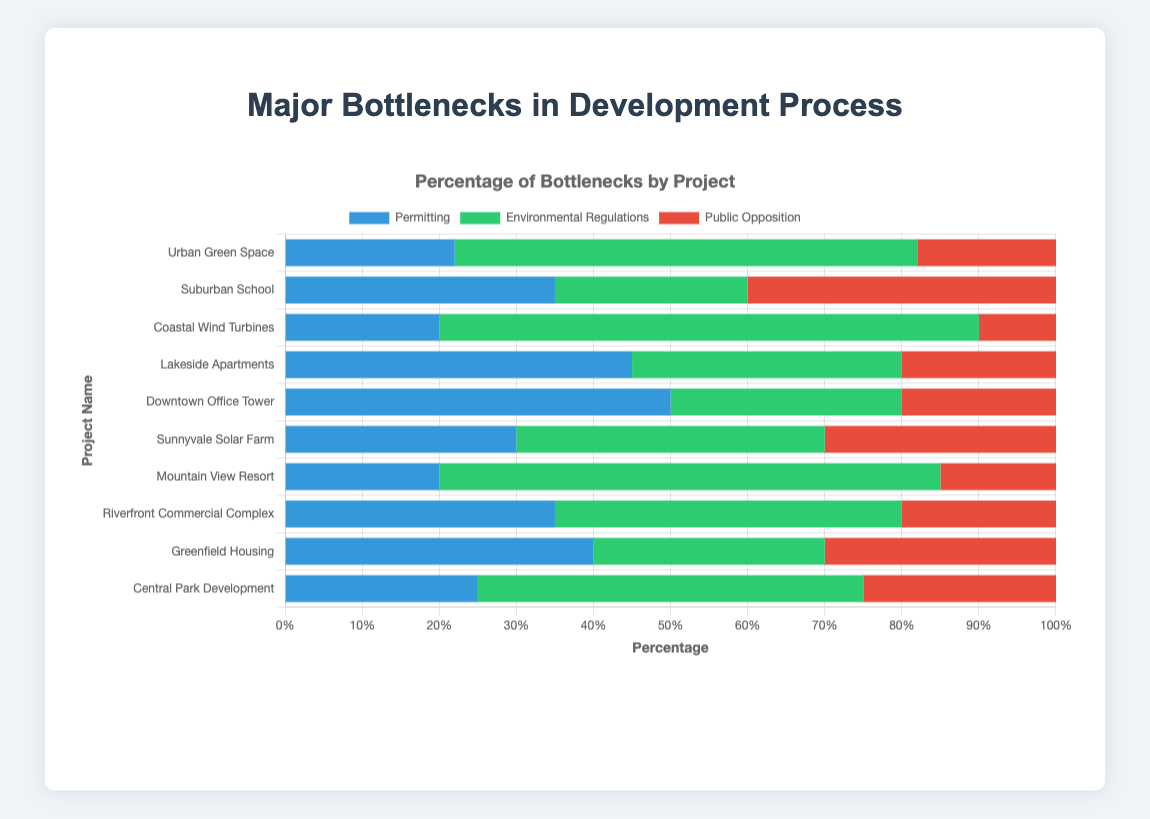Which project has the highest percentage of permitting bottlenecks? The "Permitting" section for each project is represented by the blue bar. By looking at the blue bars, the "Downtown Office Tower" has the highest percentage of permitting bottlenecks at 50%.
Answer: Downtown Office Tower Which bottleneck category has the highest percentage in the Coastal Wind Turbines project? The "Environmental Regulations" section is represented by the green bar. For the "Coastal Wind Turbines" project, the green bar is the largest, indicating that "Environmental Regulations" account for 70% of the bottlenecks.
Answer: Environmental Regulations What is the total percentage of bottlenecks due to public opposition in the Central Park Development and Suburban School projects? The percentage of public opposition in "Central Park Development" is 25%, and in "Suburban School" it is 40%. Summing these up: 25% + 40% = 65%.
Answer: 65% Which project encounters more issues with environmental regulations compared to permitting? By comparing the green and blue bars for each project, the "Mountain View Resort" has a green bar (65%) significantly larger than its blue bar (20%), indicating more issues with environmental regulations.
Answer: Mountain View Resort How does the percentage of permitting bottlenecks in Sunnyvale Solar Farm compare to Greenfield Housing? The "Permitting" section for "Sunnyvale Solar Farm" is 30% and for "Greenfield Housing" it is 40%. The percentage is higher for "Greenfield Housing".
Answer: Greenfield Housing What is the average percentage of bottlenecks due to environmental regulations across all projects? Sum the percentages for "Environmental Regulations" and divide by the number of projects. (50 + 30 + 45 + 65 + 40 + 30 + 35 + 70 + 25 + 60) / 10 = 45%.
Answer: 45% Which project has the smallest percentage of public opposition? The "Public Opposition" section is represented by the red bar. The "Coastal Wind Turbines" project has the smallest red bar at 10%.
Answer: Coastal Wind Turbines What is the range of percentages for permitting bottlenecks across all projects? The smallest percentage for "Permitting" is 20% (Mountain View Resort, Coastal Wind Turbines) and the highest is 50% (Downtown Office Tower). So the range is 50% - 20% = 30%.
Answer: 30% Which project's bottlenecks show a more balanced distribution among the three categories? Each project can be evaluated by checking how evenly spaced their bars are. The "Greenfield Housing" project shows the most balanced distribution with percentages of 40% (Permitting), 30% (Environmental Regulations), and 30% (Public Opposition).
Answer: Greenfield Housing 